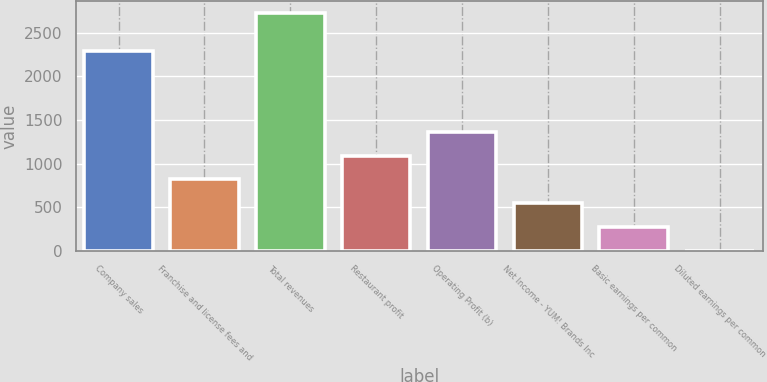<chart> <loc_0><loc_0><loc_500><loc_500><bar_chart><fcel>Company sales<fcel>Franchise and license fees and<fcel>Total revenues<fcel>Restaurant profit<fcel>Operating Profit (b)<fcel>Net Income - YUM! Brands Inc<fcel>Basic earnings per common<fcel>Diluted earnings per common<nl><fcel>2292<fcel>817.8<fcel>2724<fcel>1090.11<fcel>1362.42<fcel>545.49<fcel>273.18<fcel>0.87<nl></chart> 